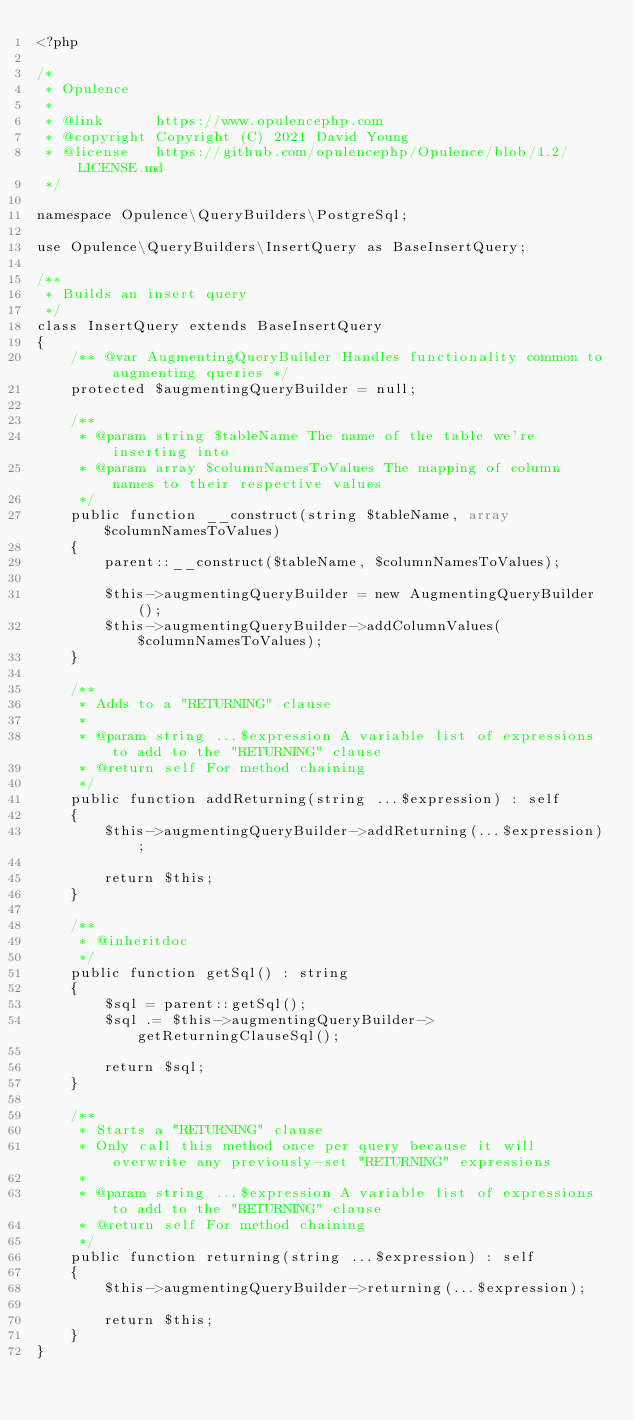Convert code to text. <code><loc_0><loc_0><loc_500><loc_500><_PHP_><?php

/*
 * Opulence
 *
 * @link      https://www.opulencephp.com
 * @copyright Copyright (C) 2021 David Young
 * @license   https://github.com/opulencephp/Opulence/blob/1.2/LICENSE.md
 */

namespace Opulence\QueryBuilders\PostgreSql;

use Opulence\QueryBuilders\InsertQuery as BaseInsertQuery;

/**
 * Builds an insert query
 */
class InsertQuery extends BaseInsertQuery
{
    /** @var AugmentingQueryBuilder Handles functionality common to augmenting queries */
    protected $augmentingQueryBuilder = null;

    /**
     * @param string $tableName The name of the table we're inserting into
     * @param array $columnNamesToValues The mapping of column names to their respective values
     */
    public function __construct(string $tableName, array $columnNamesToValues)
    {
        parent::__construct($tableName, $columnNamesToValues);

        $this->augmentingQueryBuilder = new AugmentingQueryBuilder();
        $this->augmentingQueryBuilder->addColumnValues($columnNamesToValues);
    }

    /**
     * Adds to a "RETURNING" clause
     *
     * @param string ...$expression A variable list of expressions to add to the "RETURNING" clause
     * @return self For method chaining
     */
    public function addReturning(string ...$expression) : self
    {
        $this->augmentingQueryBuilder->addReturning(...$expression);

        return $this;
    }

    /**
     * @inheritdoc
     */
    public function getSql() : string
    {
        $sql = parent::getSql();
        $sql .= $this->augmentingQueryBuilder->getReturningClauseSql();

        return $sql;
    }

    /**
     * Starts a "RETURNING" clause
     * Only call this method once per query because it will overwrite any previously-set "RETURNING" expressions
     *
     * @param string ...$expression A variable list of expressions to add to the "RETURNING" clause
     * @return self For method chaining
     */
    public function returning(string ...$expression) : self
    {
        $this->augmentingQueryBuilder->returning(...$expression);

        return $this;
    }
}
</code> 